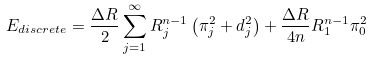Convert formula to latex. <formula><loc_0><loc_0><loc_500><loc_500>E _ { d i s c r e t e } = \frac { \Delta R } { 2 } \sum _ { j = 1 } ^ { \infty } R _ { j } ^ { n - 1 } \left ( \pi _ { j } ^ { 2 } + d _ { j } ^ { 2 } \right ) + \frac { \Delta R } { 4 n } R _ { 1 } ^ { n - 1 } \pi _ { 0 } ^ { 2 }</formula> 